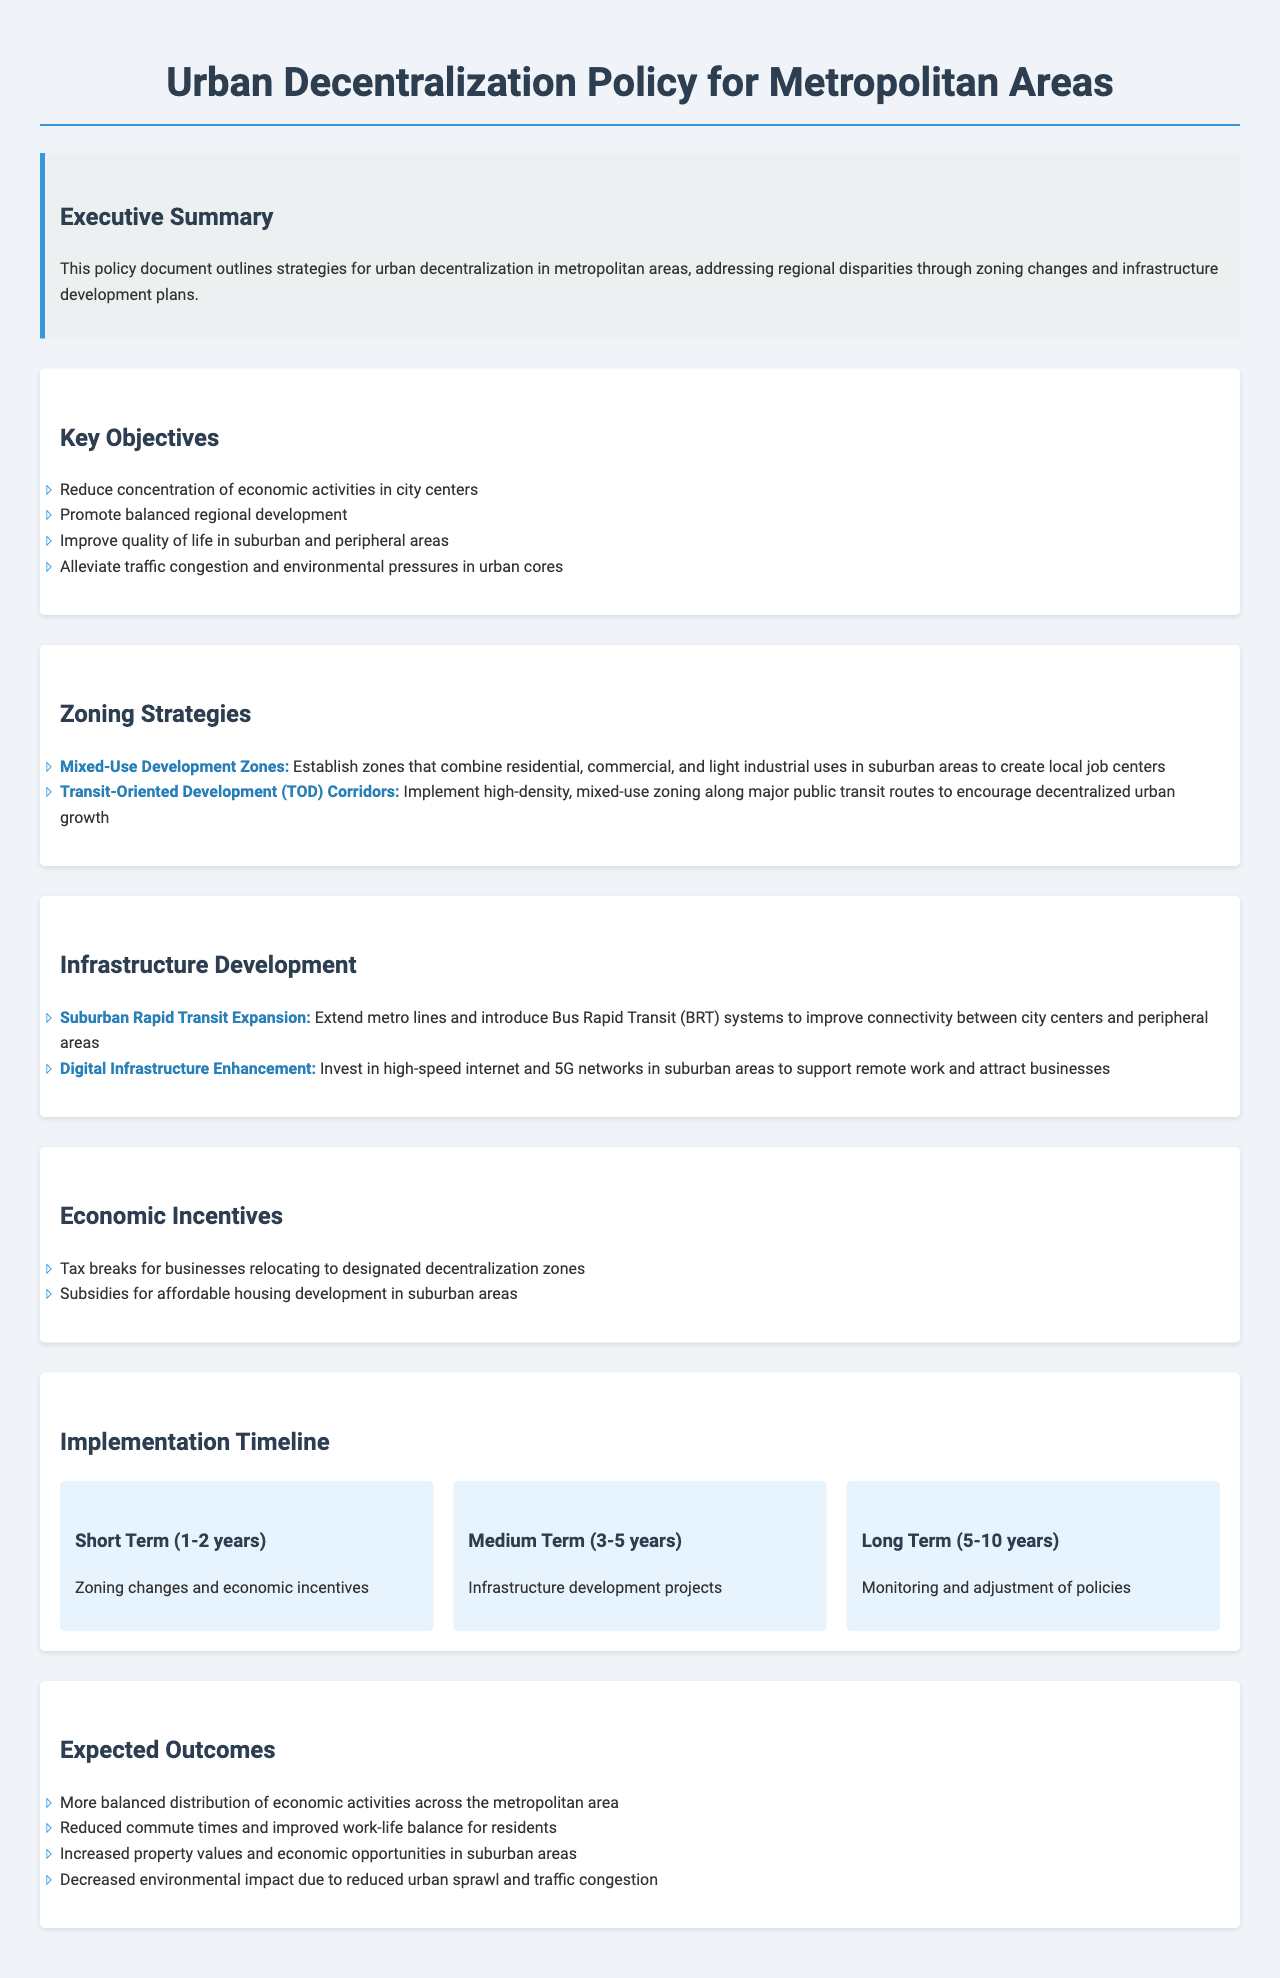What are the key objectives of the policy? The key objectives include specific aims listed in the "Key Objectives" section that promote balanced regional development and improve quality of life.
Answer: Balanced regional development What is one strategy for zoning changes? The document lists several strategies for zoning changes, detailing specific names and purposes; one example illustrates a mixed-use initiative.
Answer: Mixed-Use Development Zones How long is the short-term implementation planned for? The implementation timeline specifies durations for each phase, where the short term covers a distinct range of years.
Answer: 1-2 years What type of development is emphasized under infrastructure? The infrastructure development section highlights important projects targeted at enhancing connectivity, particularly in suburban areas.
Answer: Suburban Rapid Transit Expansion What economic incentive is mentioned in the document? Economic incentives are discussed under a dedicated section, detailing several types of support for relocation and development in designated zones.
Answer: Tax breaks What is the anticipated long-term outcome? The expected outcomes section provides insight into the overall goals and changes anticipated in the metropolitan areas due to the policy implementation.
Answer: Decreased environmental impact What is the primary focus of the executive summary? The executive summary states the overarching framework and primary strategies aimed at addressing key urban challenges within metropolitan regions.
Answer: Urban decentralization What infrastructure enhancement is planned for digital communications? The document identifies enhancements targeted at improving specific technological connectivity in suburban areas, reflecting the modern needs for internet services.
Answer: Digital Infrastructure Enhancement 